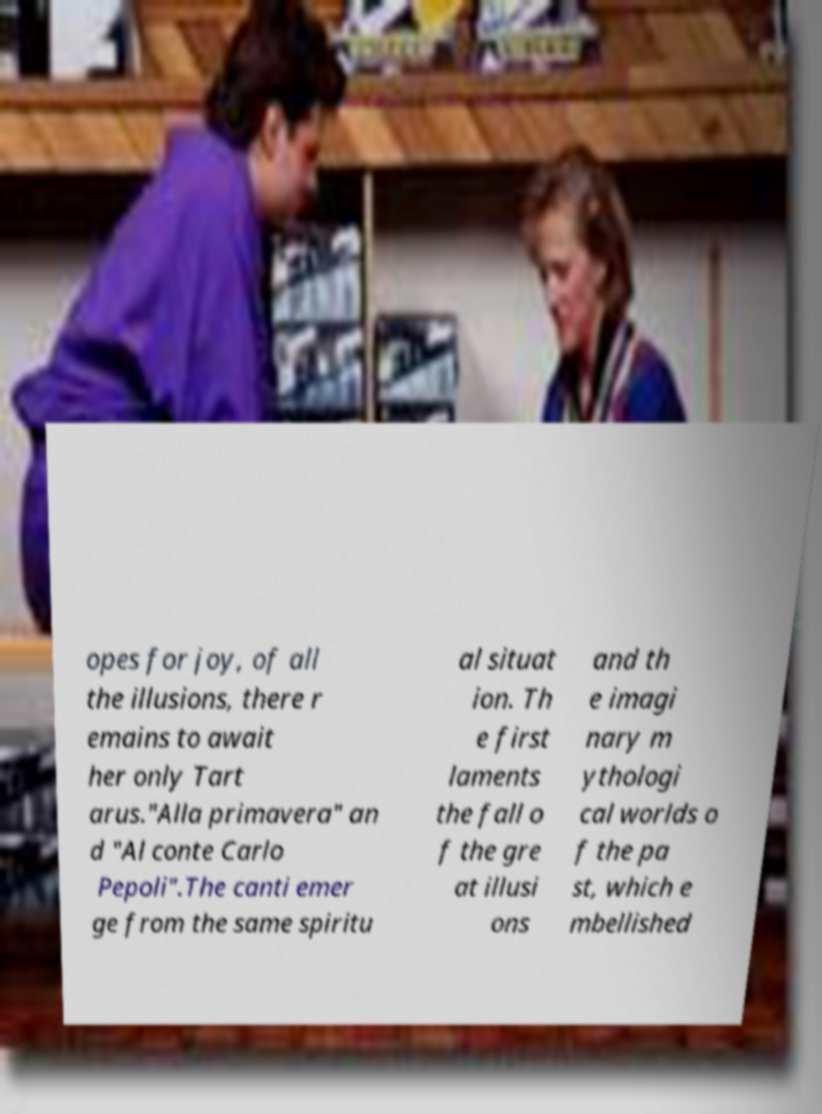There's text embedded in this image that I need extracted. Can you transcribe it verbatim? opes for joy, of all the illusions, there r emains to await her only Tart arus."Alla primavera" an d "Al conte Carlo Pepoli".The canti emer ge from the same spiritu al situat ion. Th e first laments the fall o f the gre at illusi ons and th e imagi nary m ythologi cal worlds o f the pa st, which e mbellished 